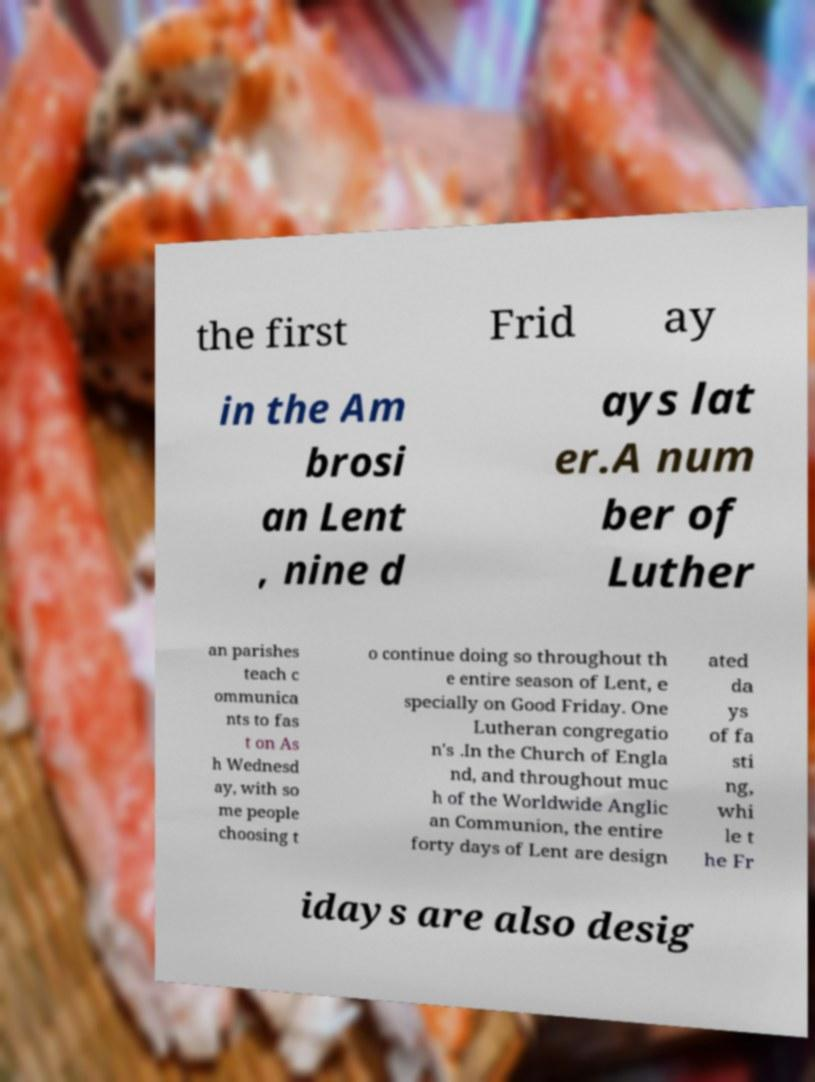Please identify and transcribe the text found in this image. the first Frid ay in the Am brosi an Lent , nine d ays lat er.A num ber of Luther an parishes teach c ommunica nts to fas t on As h Wednesd ay, with so me people choosing t o continue doing so throughout th e entire season of Lent, e specially on Good Friday. One Lutheran congregatio n's .In the Church of Engla nd, and throughout muc h of the Worldwide Anglic an Communion, the entire forty days of Lent are design ated da ys of fa sti ng, whi le t he Fr idays are also desig 